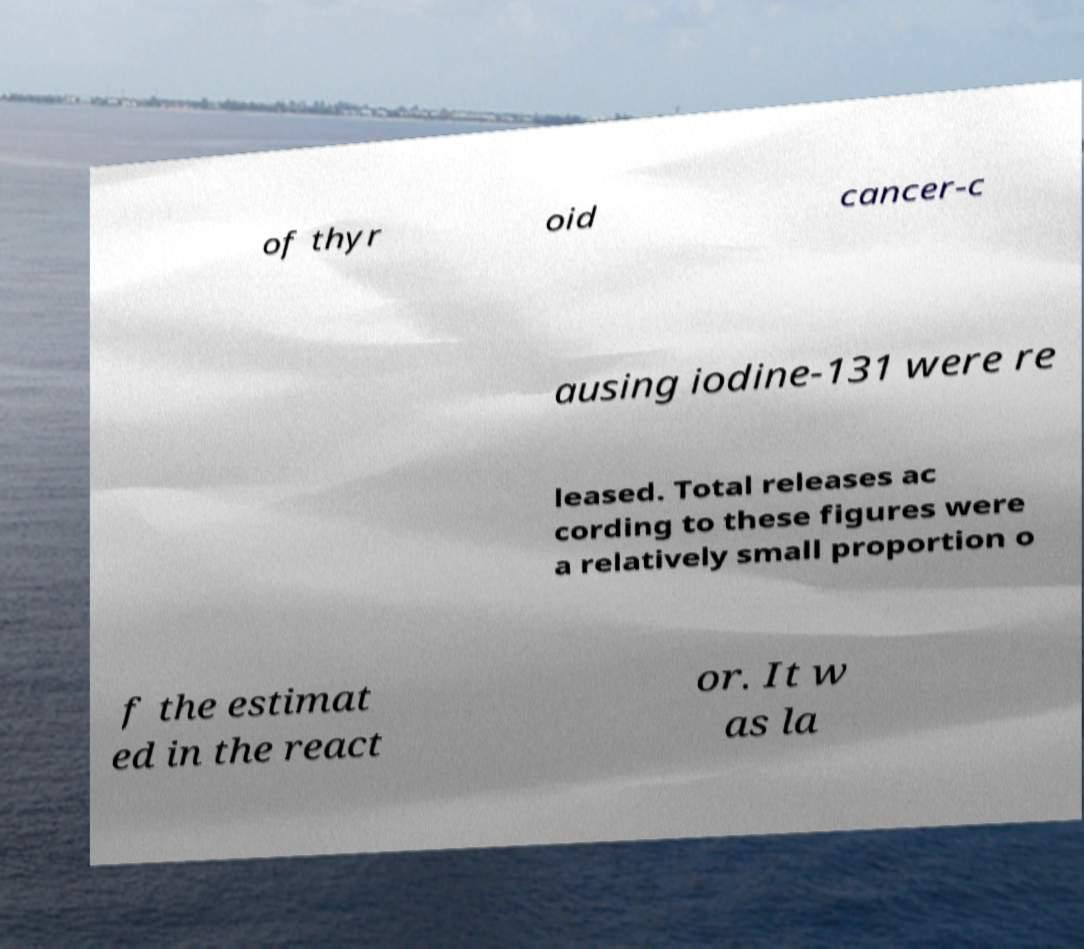What messages or text are displayed in this image? I need them in a readable, typed format. of thyr oid cancer-c ausing iodine-131 were re leased. Total releases ac cording to these figures were a relatively small proportion o f the estimat ed in the react or. It w as la 